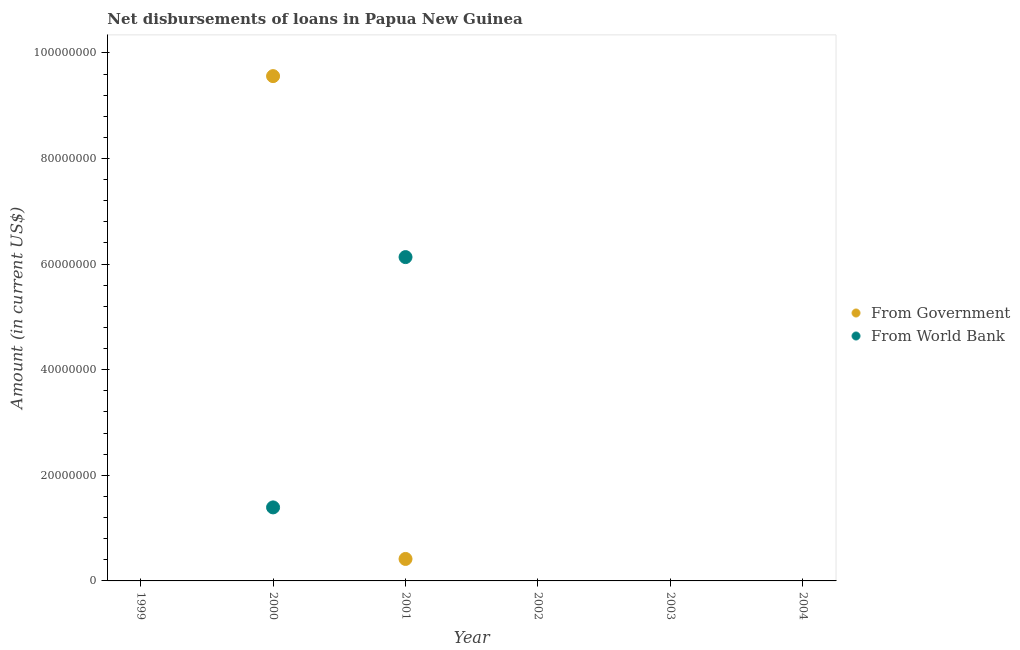What is the net disbursements of loan from government in 2004?
Provide a short and direct response. 0. Across all years, what is the maximum net disbursements of loan from government?
Offer a very short reply. 9.56e+07. In which year was the net disbursements of loan from world bank maximum?
Your response must be concise. 2001. What is the total net disbursements of loan from government in the graph?
Your answer should be very brief. 9.98e+07. What is the difference between the net disbursements of loan from world bank in 2000 and that in 2001?
Offer a terse response. -4.74e+07. What is the average net disbursements of loan from world bank per year?
Your answer should be compact. 1.25e+07. In the year 2000, what is the difference between the net disbursements of loan from world bank and net disbursements of loan from government?
Provide a succinct answer. -8.17e+07. Is the difference between the net disbursements of loan from government in 2000 and 2001 greater than the difference between the net disbursements of loan from world bank in 2000 and 2001?
Offer a very short reply. Yes. What is the difference between the highest and the lowest net disbursements of loan from world bank?
Make the answer very short. 6.13e+07. In how many years, is the net disbursements of loan from government greater than the average net disbursements of loan from government taken over all years?
Provide a succinct answer. 1. Is the net disbursements of loan from government strictly greater than the net disbursements of loan from world bank over the years?
Offer a very short reply. No. How many dotlines are there?
Make the answer very short. 2. How many years are there in the graph?
Offer a very short reply. 6. What is the difference between two consecutive major ticks on the Y-axis?
Ensure brevity in your answer.  2.00e+07. Does the graph contain grids?
Offer a very short reply. No. How many legend labels are there?
Keep it short and to the point. 2. How are the legend labels stacked?
Offer a very short reply. Vertical. What is the title of the graph?
Your answer should be compact. Net disbursements of loans in Papua New Guinea. What is the label or title of the X-axis?
Make the answer very short. Year. What is the label or title of the Y-axis?
Give a very brief answer. Amount (in current US$). What is the Amount (in current US$) in From Government in 1999?
Provide a succinct answer. 0. What is the Amount (in current US$) in From Government in 2000?
Keep it short and to the point. 9.56e+07. What is the Amount (in current US$) of From World Bank in 2000?
Your response must be concise. 1.39e+07. What is the Amount (in current US$) of From Government in 2001?
Your answer should be compact. 4.16e+06. What is the Amount (in current US$) in From World Bank in 2001?
Your answer should be compact. 6.13e+07. What is the Amount (in current US$) of From Government in 2004?
Your answer should be very brief. 0. Across all years, what is the maximum Amount (in current US$) in From Government?
Make the answer very short. 9.56e+07. Across all years, what is the maximum Amount (in current US$) of From World Bank?
Offer a terse response. 6.13e+07. Across all years, what is the minimum Amount (in current US$) in From Government?
Ensure brevity in your answer.  0. What is the total Amount (in current US$) of From Government in the graph?
Give a very brief answer. 9.98e+07. What is the total Amount (in current US$) of From World Bank in the graph?
Provide a short and direct response. 7.53e+07. What is the difference between the Amount (in current US$) in From Government in 2000 and that in 2001?
Make the answer very short. 9.14e+07. What is the difference between the Amount (in current US$) of From World Bank in 2000 and that in 2001?
Offer a very short reply. -4.74e+07. What is the difference between the Amount (in current US$) of From Government in 2000 and the Amount (in current US$) of From World Bank in 2001?
Provide a short and direct response. 3.43e+07. What is the average Amount (in current US$) in From Government per year?
Make the answer very short. 1.66e+07. What is the average Amount (in current US$) of From World Bank per year?
Ensure brevity in your answer.  1.25e+07. In the year 2000, what is the difference between the Amount (in current US$) in From Government and Amount (in current US$) in From World Bank?
Provide a short and direct response. 8.17e+07. In the year 2001, what is the difference between the Amount (in current US$) in From Government and Amount (in current US$) in From World Bank?
Make the answer very short. -5.72e+07. What is the ratio of the Amount (in current US$) of From Government in 2000 to that in 2001?
Provide a succinct answer. 22.97. What is the ratio of the Amount (in current US$) of From World Bank in 2000 to that in 2001?
Give a very brief answer. 0.23. What is the difference between the highest and the lowest Amount (in current US$) of From Government?
Your answer should be compact. 9.56e+07. What is the difference between the highest and the lowest Amount (in current US$) in From World Bank?
Ensure brevity in your answer.  6.13e+07. 